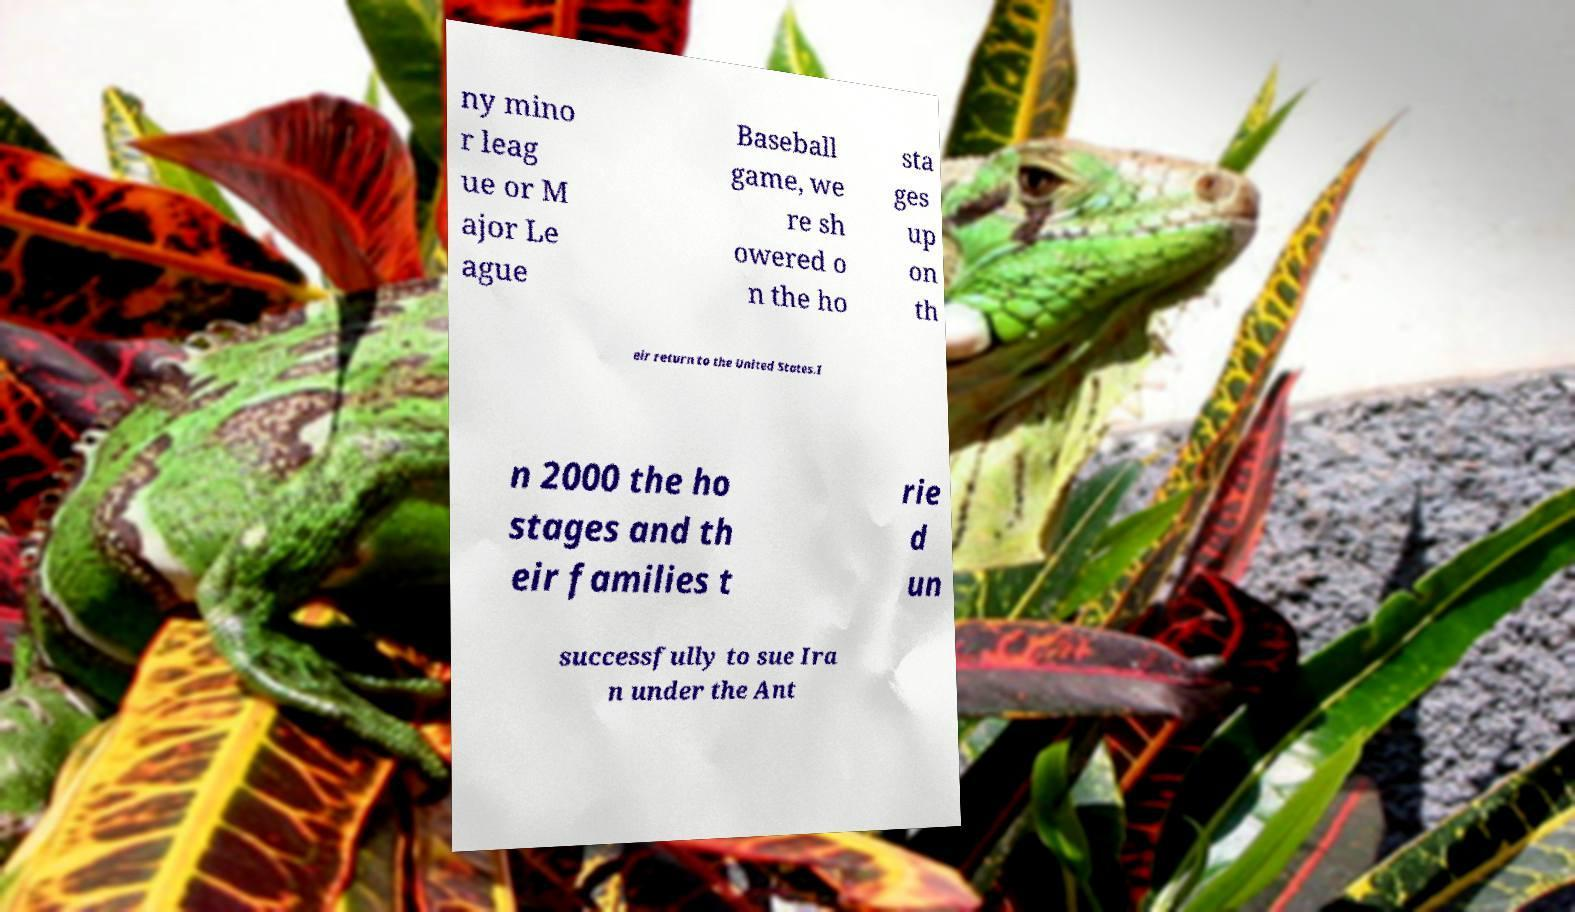Please read and relay the text visible in this image. What does it say? ny mino r leag ue or M ajor Le ague Baseball game, we re sh owered o n the ho sta ges up on th eir return to the United States.I n 2000 the ho stages and th eir families t rie d un successfully to sue Ira n under the Ant 